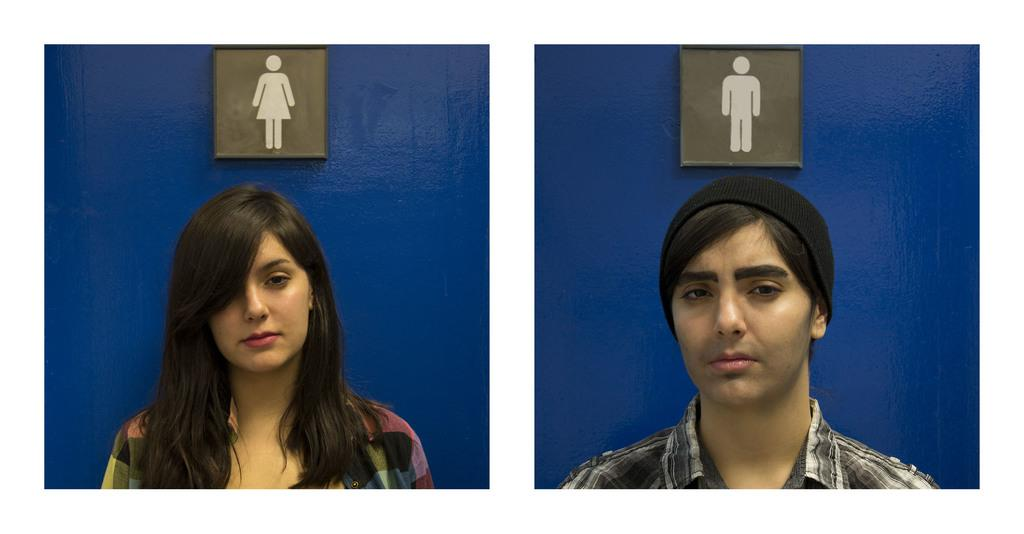How many people are in the image? There are two persons in the image. What color is the wall in the image? The wall in the image is blue. What is attached to the wall in the image? There are boards on the wall in the image. What is the result of adding 5 and 7 in the image? There is no addition or mathematical operation being performed in the image. The image only shows two persons and a blue wall with boards. 